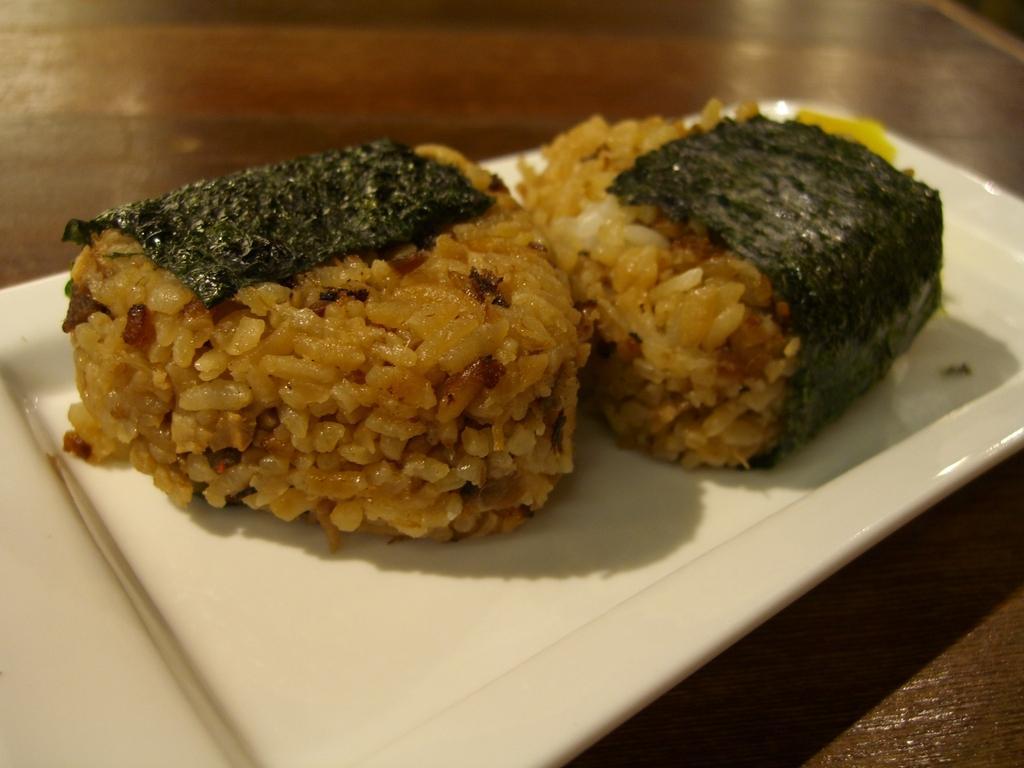Can you describe this image briefly? In this image I can see the plate with food. The plate is in white color and the food is in brown and green color. The plate is on the table. 